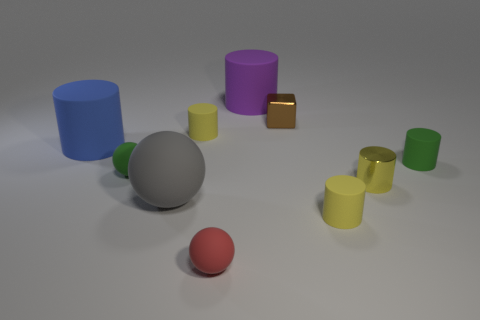Is there anything else that is the same shape as the small brown metallic object?
Your answer should be compact. No. There is a small yellow matte cylinder that is in front of the green rubber cylinder; what number of small cylinders are in front of it?
Your answer should be very brief. 0. There is a matte object that is to the right of the small red thing and on the left side of the shiny cube; what size is it?
Provide a short and direct response. Large. What number of metallic things are either small green things or blue things?
Ensure brevity in your answer.  0. What is the tiny red thing made of?
Make the answer very short. Rubber. There is a tiny green thing on the left side of the large object that is on the right side of the tiny yellow rubber thing on the left side of the block; what is its material?
Your response must be concise. Rubber. What shape is the gray object that is the same size as the purple matte cylinder?
Your response must be concise. Sphere. What number of things are either gray metal cylinders or small cylinders that are behind the green cylinder?
Your response must be concise. 1. Are the tiny cylinder that is behind the green cylinder and the tiny cube to the right of the gray matte ball made of the same material?
Offer a very short reply. No. What number of purple objects are large cylinders or matte cylinders?
Give a very brief answer. 1. 